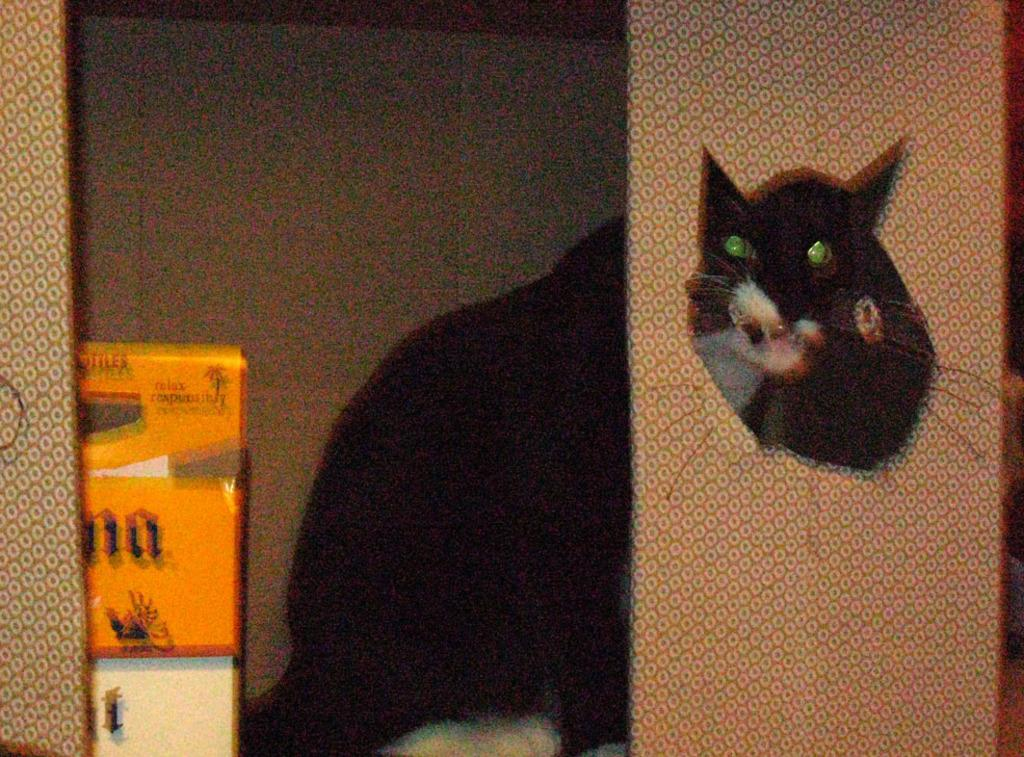What is the main object in the image? There is a cardboard sheet in the image. What type of animal is present in the image? There is a cat in the image. What can be seen beside the cat? There are objects beside the cat in the image. What is visible in the background of the image? There is a wall in the background of the image. What type of scarf is the cat wearing in the image? There is no scarf present in the image; the cat is not wearing any clothing. How many hands are visible in the image? There is no mention of hands in the provided facts, so it cannot be determined how many hands are visible in the image. 